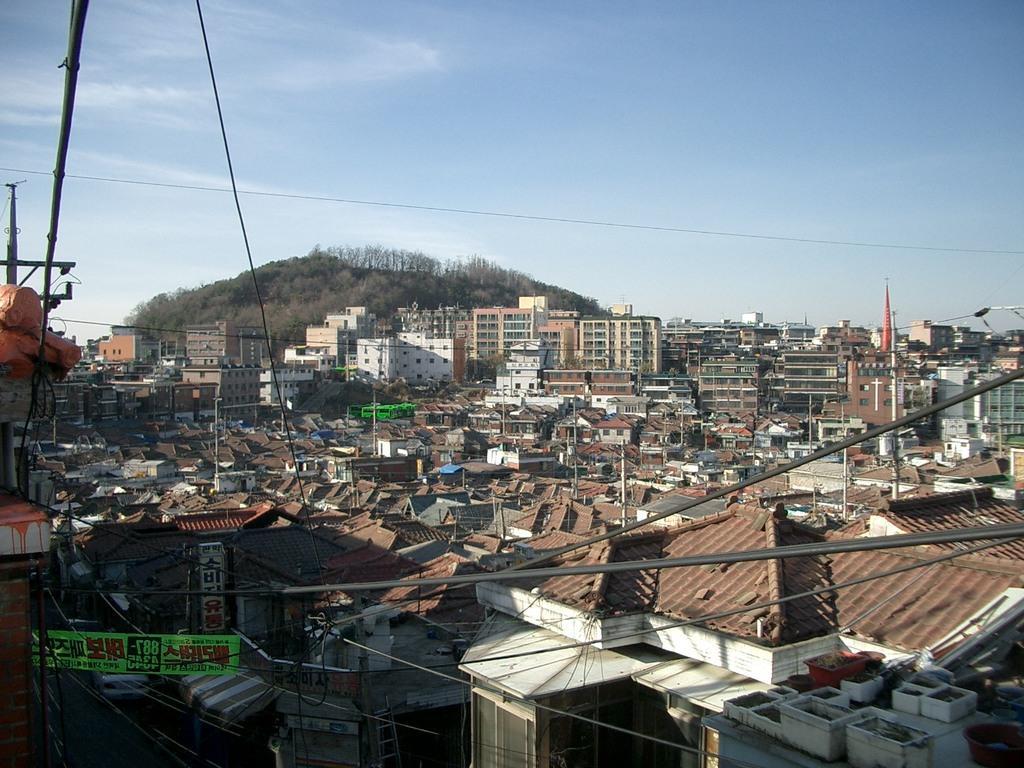Please provide a concise description of this image. In this image I can see metal rods, wires, houses, buildings, trees, mountains and the sky. This image is taken may be during a day. 